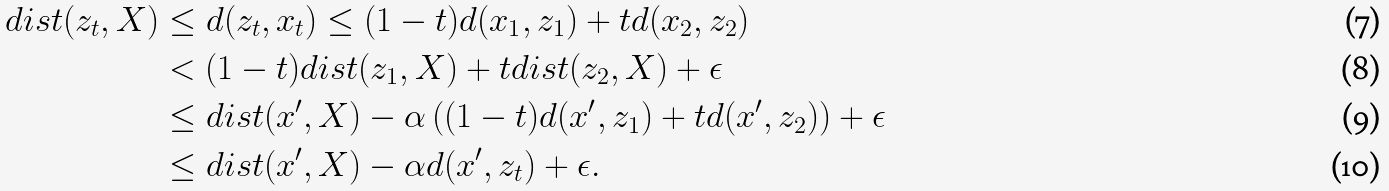<formula> <loc_0><loc_0><loc_500><loc_500>d i s t ( z _ { t } , X ) & \leq d ( z _ { t } , x _ { t } ) \leq ( 1 - t ) d ( x _ { 1 } , z _ { 1 } ) + t d ( x _ { 2 } , z _ { 2 } ) \\ & < ( 1 - t ) d i s t ( z _ { 1 } , X ) + t d i s t ( z _ { 2 } , X ) + \epsilon \\ & \leq d i s t ( x ^ { \prime } , X ) - \alpha \left ( ( 1 - t ) d ( x ^ { \prime } , z _ { 1 } ) + t d ( x ^ { \prime } , z _ { 2 } ) \right ) + \epsilon \\ & \leq d i s t ( x ^ { \prime } , X ) - \alpha d ( x ^ { \prime } , z _ { t } ) + \epsilon .</formula> 